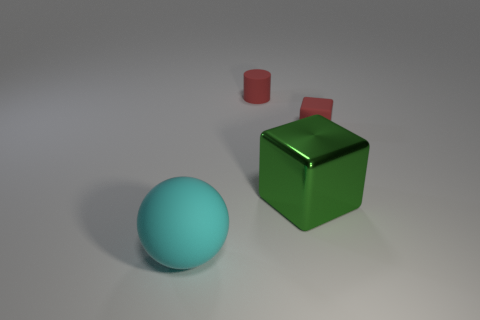Add 3 large blue balls. How many objects exist? 7 Subtract all cylinders. How many objects are left? 3 Subtract all small brown shiny things. Subtract all small red things. How many objects are left? 2 Add 3 red rubber things. How many red rubber things are left? 5 Add 4 tiny red matte cylinders. How many tiny red matte cylinders exist? 5 Subtract 0 purple cylinders. How many objects are left? 4 